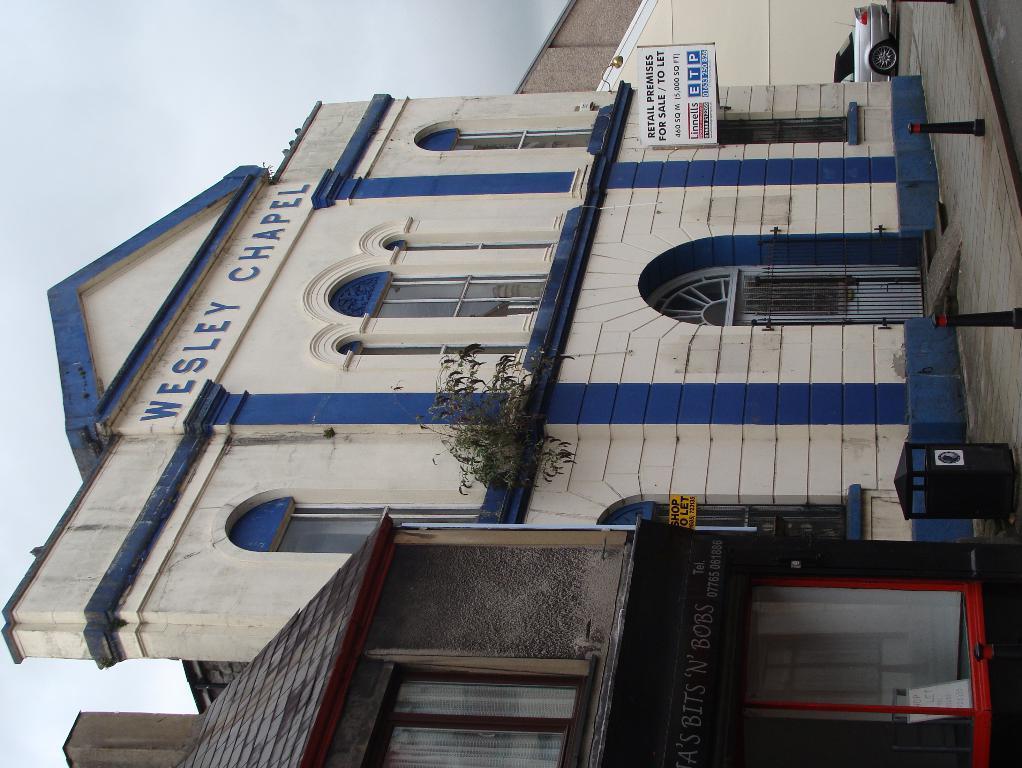Please provide a concise description of this image. In this image I can see the building. I can see the board to the building. To the side there is a vehicle. In the background I can see the sky. 